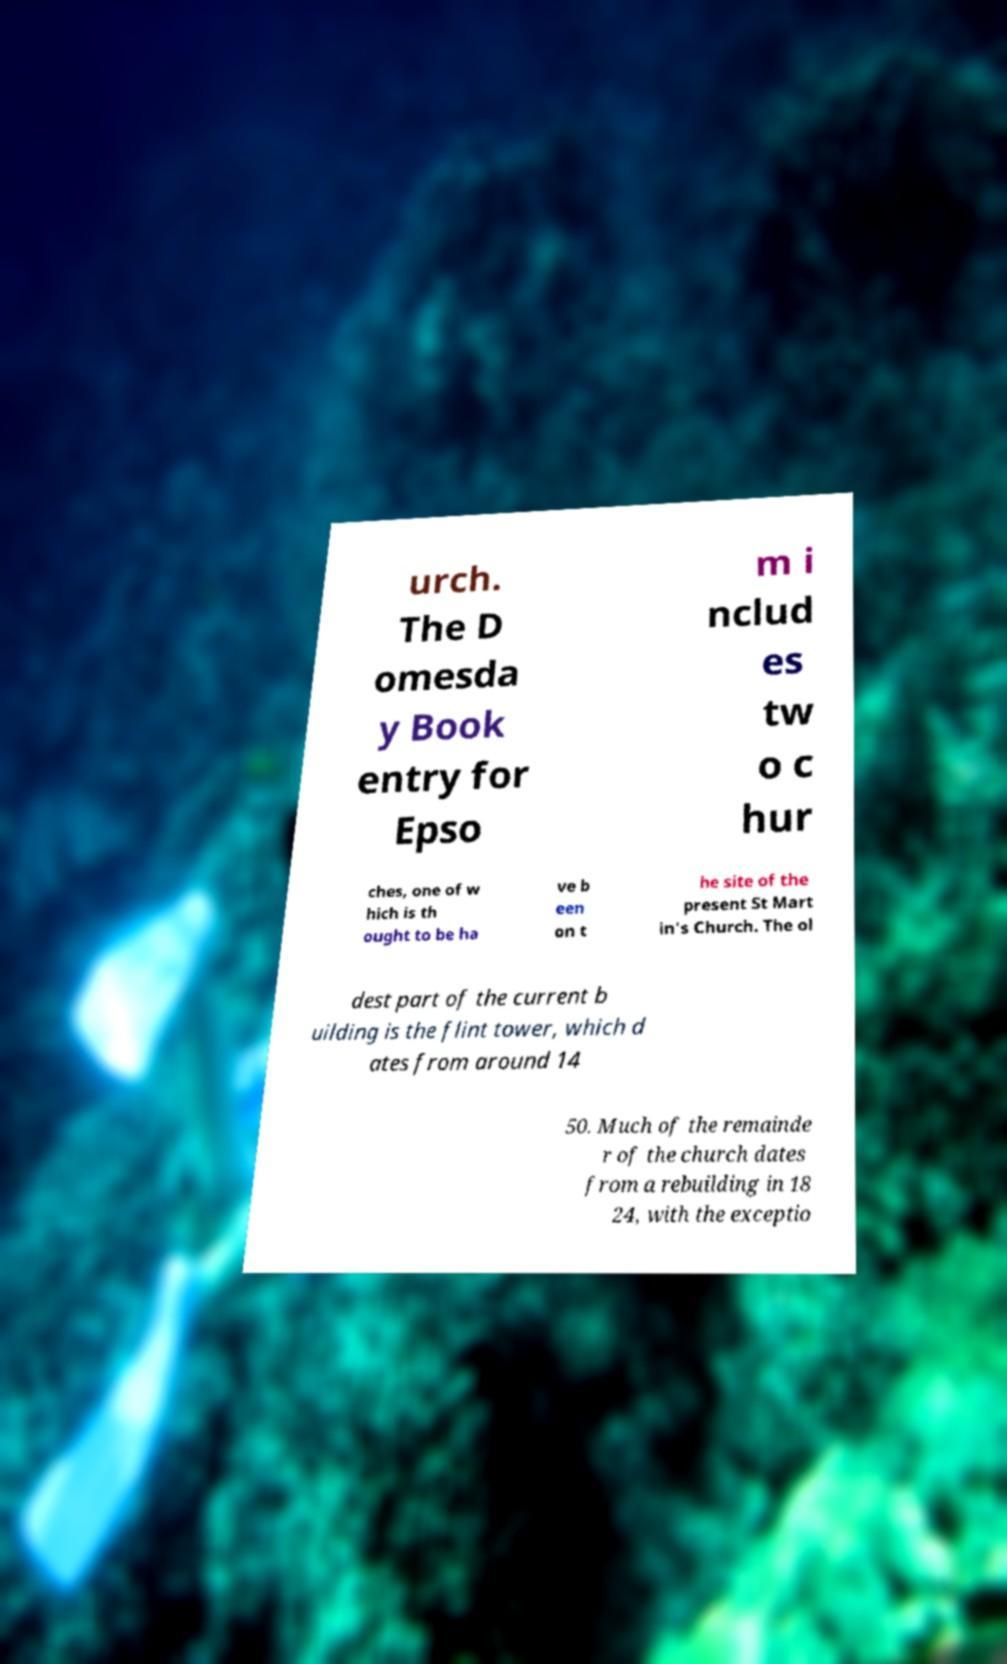Can you accurately transcribe the text from the provided image for me? urch. The D omesda y Book entry for Epso m i nclud es tw o c hur ches, one of w hich is th ought to be ha ve b een on t he site of the present St Mart in's Church. The ol dest part of the current b uilding is the flint tower, which d ates from around 14 50. Much of the remainde r of the church dates from a rebuilding in 18 24, with the exceptio 